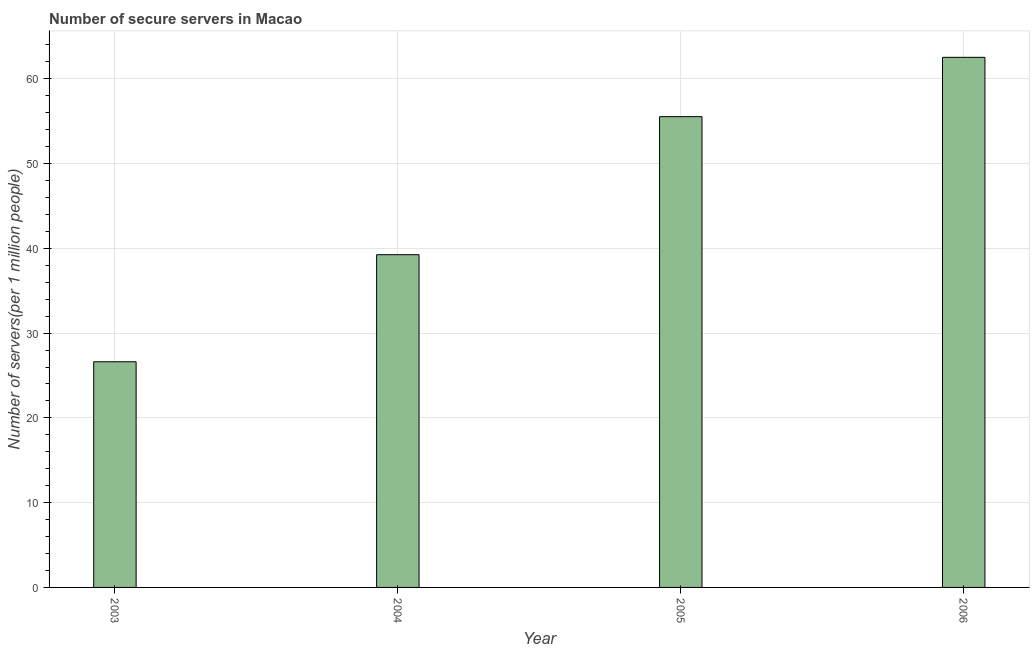What is the title of the graph?
Give a very brief answer. Number of secure servers in Macao. What is the label or title of the Y-axis?
Provide a short and direct response. Number of servers(per 1 million people). What is the number of secure internet servers in 2006?
Give a very brief answer. 62.54. Across all years, what is the maximum number of secure internet servers?
Give a very brief answer. 62.54. Across all years, what is the minimum number of secure internet servers?
Your response must be concise. 26.62. In which year was the number of secure internet servers maximum?
Your answer should be very brief. 2006. In which year was the number of secure internet servers minimum?
Offer a very short reply. 2003. What is the sum of the number of secure internet servers?
Ensure brevity in your answer.  183.95. What is the difference between the number of secure internet servers in 2004 and 2005?
Make the answer very short. -16.29. What is the average number of secure internet servers per year?
Your answer should be very brief. 45.99. What is the median number of secure internet servers?
Provide a succinct answer. 47.39. Do a majority of the years between 2003 and 2005 (inclusive) have number of secure internet servers greater than 48 ?
Your answer should be compact. No. What is the ratio of the number of secure internet servers in 2004 to that in 2005?
Provide a succinct answer. 0.71. Is the number of secure internet servers in 2004 less than that in 2006?
Your response must be concise. Yes. What is the difference between the highest and the second highest number of secure internet servers?
Your answer should be compact. 7. What is the difference between the highest and the lowest number of secure internet servers?
Provide a short and direct response. 35.91. What is the Number of servers(per 1 million people) of 2003?
Ensure brevity in your answer.  26.62. What is the Number of servers(per 1 million people) of 2004?
Provide a succinct answer. 39.25. What is the Number of servers(per 1 million people) in 2005?
Offer a very short reply. 55.54. What is the Number of servers(per 1 million people) in 2006?
Make the answer very short. 62.54. What is the difference between the Number of servers(per 1 million people) in 2003 and 2004?
Keep it short and to the point. -12.63. What is the difference between the Number of servers(per 1 million people) in 2003 and 2005?
Provide a succinct answer. -28.92. What is the difference between the Number of servers(per 1 million people) in 2003 and 2006?
Ensure brevity in your answer.  -35.91. What is the difference between the Number of servers(per 1 million people) in 2004 and 2005?
Make the answer very short. -16.29. What is the difference between the Number of servers(per 1 million people) in 2004 and 2006?
Provide a succinct answer. -23.28. What is the difference between the Number of servers(per 1 million people) in 2005 and 2006?
Give a very brief answer. -7. What is the ratio of the Number of servers(per 1 million people) in 2003 to that in 2004?
Your response must be concise. 0.68. What is the ratio of the Number of servers(per 1 million people) in 2003 to that in 2005?
Offer a very short reply. 0.48. What is the ratio of the Number of servers(per 1 million people) in 2003 to that in 2006?
Your response must be concise. 0.43. What is the ratio of the Number of servers(per 1 million people) in 2004 to that in 2005?
Your answer should be very brief. 0.71. What is the ratio of the Number of servers(per 1 million people) in 2004 to that in 2006?
Offer a terse response. 0.63. What is the ratio of the Number of servers(per 1 million people) in 2005 to that in 2006?
Offer a terse response. 0.89. 